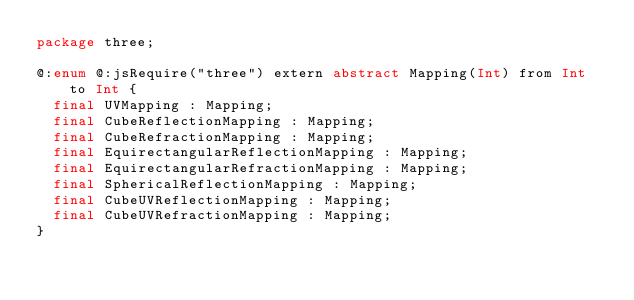<code> <loc_0><loc_0><loc_500><loc_500><_Haxe_>package three;

@:enum @:jsRequire("three") extern abstract Mapping(Int) from Int to Int {
	final UVMapping : Mapping;
	final CubeReflectionMapping : Mapping;
	final CubeRefractionMapping : Mapping;
	final EquirectangularReflectionMapping : Mapping;
	final EquirectangularRefractionMapping : Mapping;
	final SphericalReflectionMapping : Mapping;
	final CubeUVReflectionMapping : Mapping;
	final CubeUVRefractionMapping : Mapping;
}</code> 